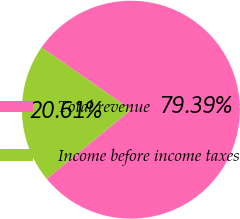Convert chart to OTSL. <chart><loc_0><loc_0><loc_500><loc_500><pie_chart><fcel>Total revenue<fcel>Income before income taxes<nl><fcel>79.39%<fcel>20.61%<nl></chart> 